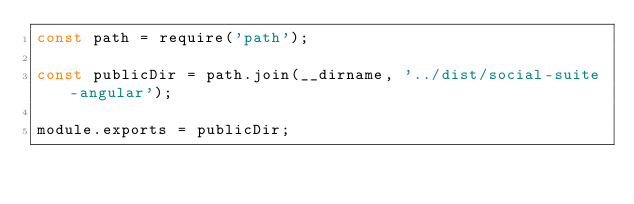Convert code to text. <code><loc_0><loc_0><loc_500><loc_500><_JavaScript_>const path = require('path');

const publicDir = path.join(__dirname, '../dist/social-suite-angular');

module.exports = publicDir;
</code> 